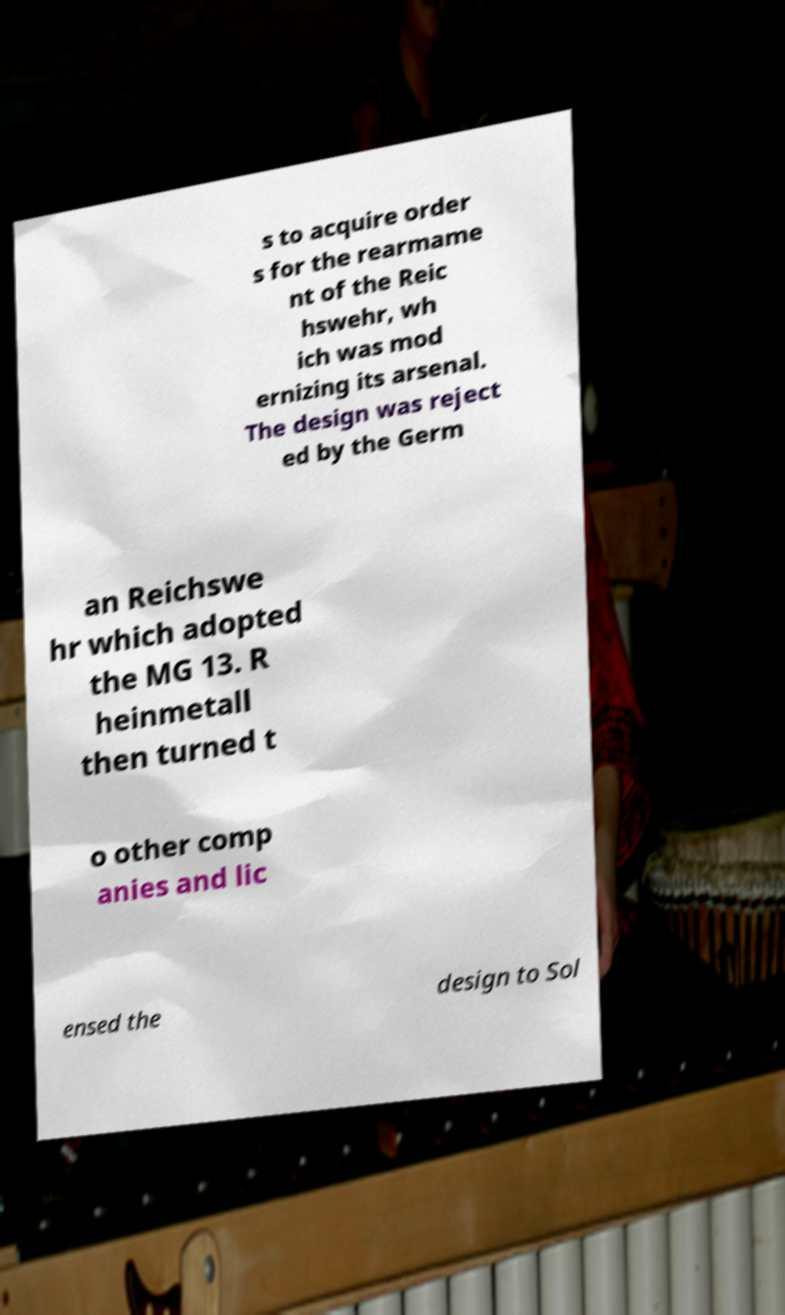Can you accurately transcribe the text from the provided image for me? s to acquire order s for the rearmame nt of the Reic hswehr, wh ich was mod ernizing its arsenal. The design was reject ed by the Germ an Reichswe hr which adopted the MG 13. R heinmetall then turned t o other comp anies and lic ensed the design to Sol 